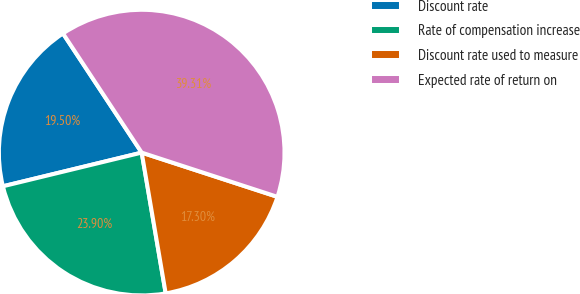<chart> <loc_0><loc_0><loc_500><loc_500><pie_chart><fcel>Discount rate<fcel>Rate of compensation increase<fcel>Discount rate used to measure<fcel>Expected rate of return on<nl><fcel>19.5%<fcel>23.9%<fcel>17.3%<fcel>39.31%<nl></chart> 